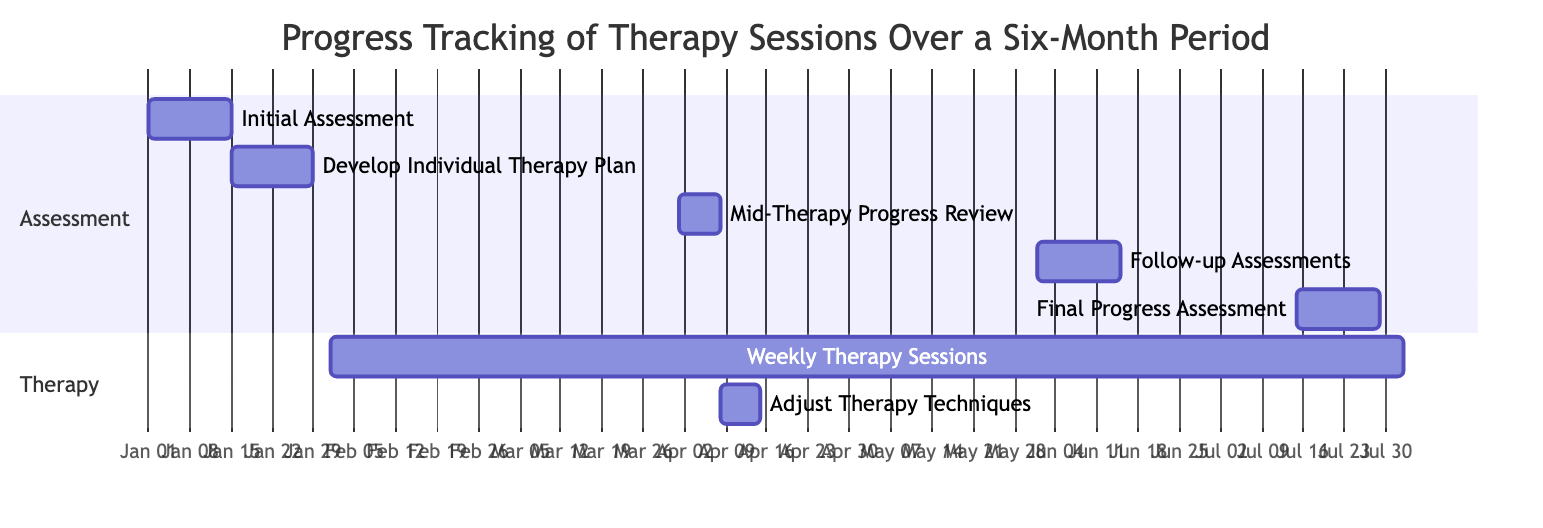What is the duration of the "Initial Assessment" task? The "Initial Assessment" task is labeled with a duration of "2 weeks" in the diagram.
Answer: 2 weeks How many weeks does the "Weekly Therapy Sessions" last? The "Weekly Therapy Sessions" task is marked as lasting "26 weeks" according to the diagram.
Answer: 26 weeks What is the start date of the "Follow-up Assessments"? The diagram indicates that the "Follow-up Assessments" task starts on "2023-06-01".
Answer: 2023-06-01 Which task follows the "Mid-Therapy Progress Review"? After the "Mid-Therapy Progress Review," the next task in the timeline is "Adjust Therapy Techniques," as it starts immediately after the review ends.
Answer: Adjust Therapy Techniques What is the relationship between "Develop Individual Therapy Plan" and "Weekly Therapy Sessions"? "Weekly Therapy Sessions" begins immediately after "Develop Individual Therapy Plan," signifying a direct sequential relationship where the former follows the completion of the latter.
Answer: Sequential relationship Which assessment occurs right before the "Final Progress Assessment"? The "Follow-up Assessments," which takes place before the "Final Progress Assessment" based on the timeline in the diagram.
Answer: Follow-up Assessments How long is the gap between the "Mid-Therapy Progress Review" and "Adjust Therapy Techniques"? The "Mid-Therapy Progress Review" ends on "2023-04-07," and "Adjust Therapy Techniques" starts on "2023-04-08," indicating no gap between these two tasks as they are consecutive.
Answer: No gap How many tasks are categorized under the "Assessment" section? There are a total of five tasks listed in the "Assessment" section: Initial Assessment, Develop Individual Therapy Plan, Mid-Therapy Progress Review, Follow-up Assessments, and Final Progress Assessment.
Answer: Five tasks What is the total number of weeks covered in this Gantt chart? To calculate the total weeks, the last task "Weekly Therapy Sessions" runs for 26 weeks, starting from February 1 to July 31, which leads to a total duration of 26 weeks in tracking progress for therapy sessions.
Answer: 26 weeks 